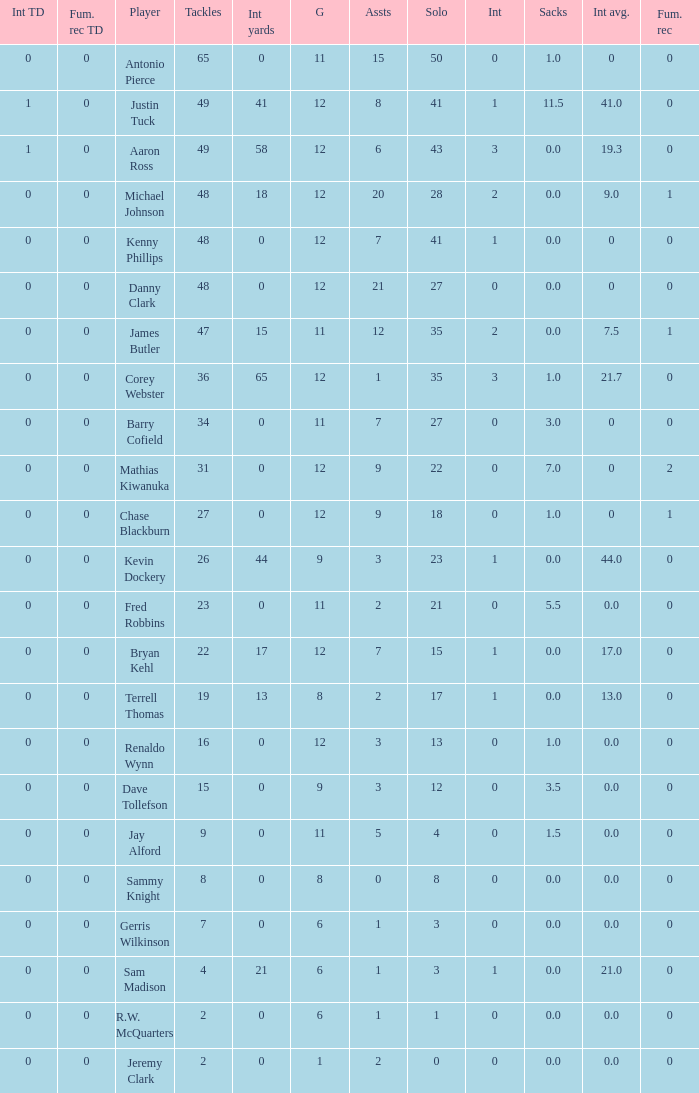Name the least amount of tackles for danny clark 48.0. 